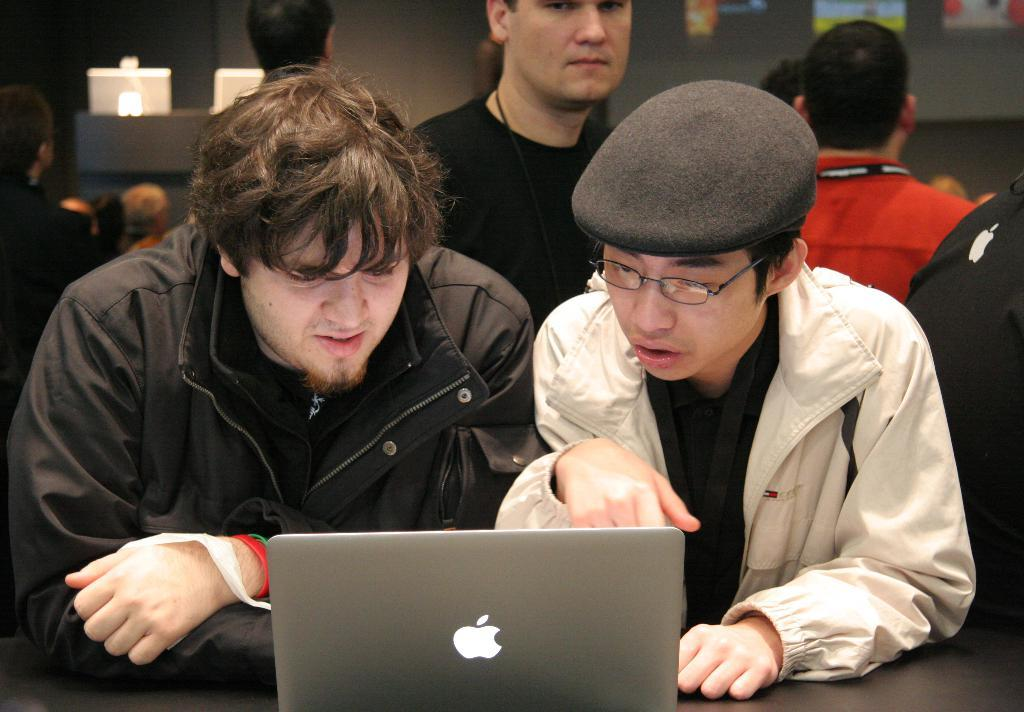Who or what is present in the image? There are people in the image. What electronic devices can be seen in the image? There are laptops in the image. Is there any other notable feature in the image? Yes, there is a screen on the backside in the image. How many frogs can be seen on the laptops in the image? There are no frogs present on the laptops or in the image. What type of pest is visible on the screen in the image? There is no pest visible on the screen or in the image. 